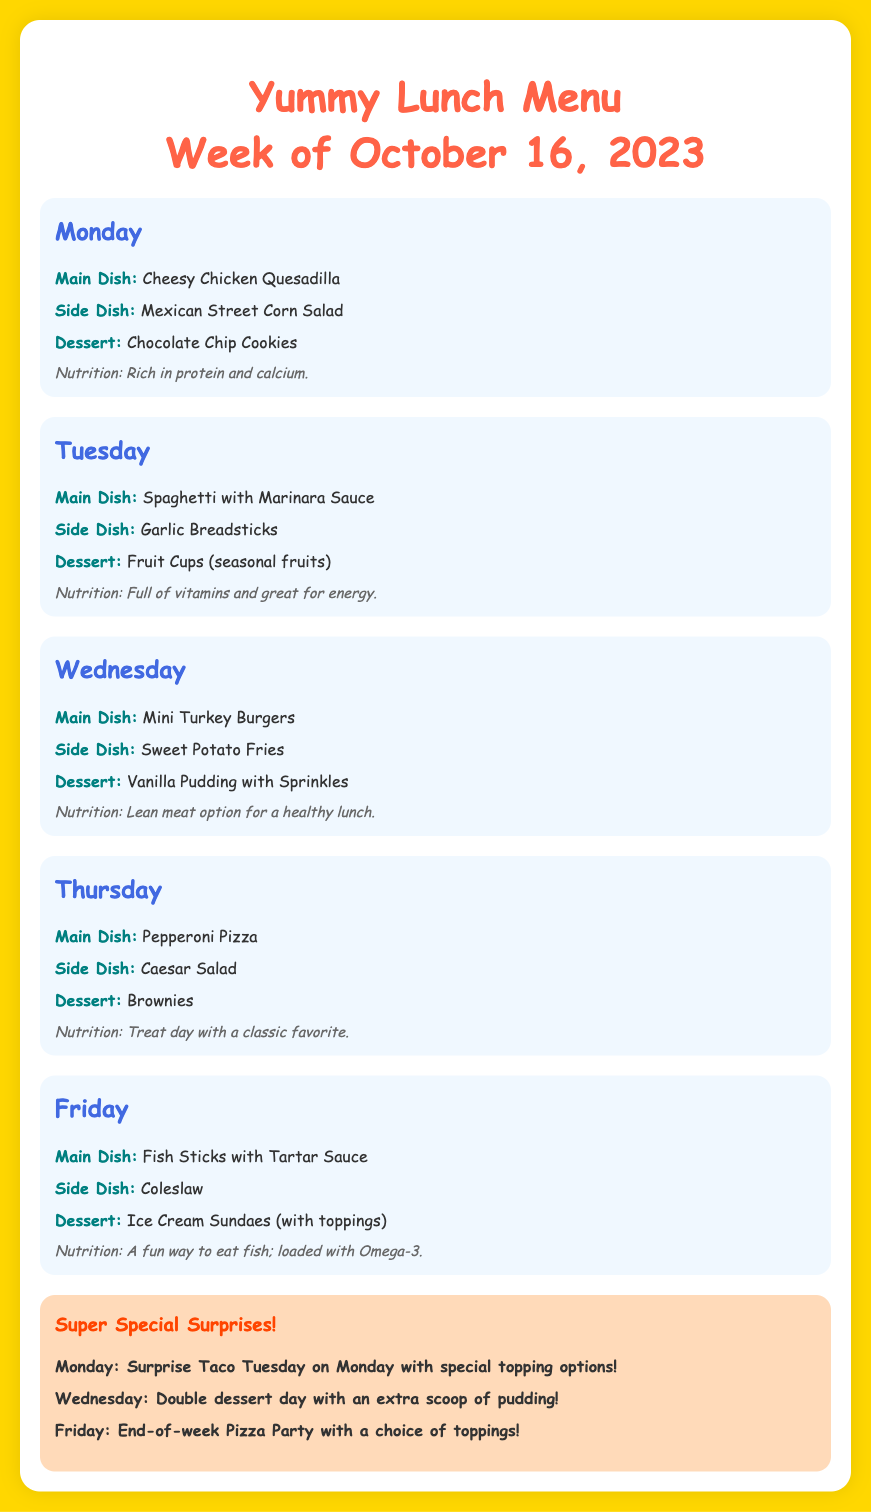What is the main dish on Monday? The main dish for Monday is mentioned in the document as "Cheesy Chicken Quesadilla."
Answer: Cheesy Chicken Quesadilla What dessert is served on Tuesday? The dessert for Tuesday is provided as "Fruit Cups (seasonal fruits)."
Answer: Fruit Cups (seasonal fruits) What colorful dessert is served on Wednesday? The document describes the dessert for Wednesday as "Vanilla Pudding with Sprinkles."
Answer: Vanilla Pudding with Sprinkles How many special surprises are there for the week? The document lists three specials that occur throughout the week.
Answer: 3 What is the side dish on Friday? The side dish for Friday, according to the document, is "Coleslaw."
Answer: Coleslaw What is the theme of the surprise on Monday? The surprise for Monday is related to a "Surprise Taco Tuesday on Monday."
Answer: Surprise Taco Tuesday Which day has a double dessert? The document indicates that Wednesday is the day with "Double dessert day."
Answer: Wednesday What type of pizza is served on Thursday? The main dish for Thursday in the document is "Pepperoni Pizza."
Answer: Pepperoni Pizza What do the ice cream sundaes come with on Friday? The document specifies that the ice cream sundaes come with "toppings."
Answer: toppings 